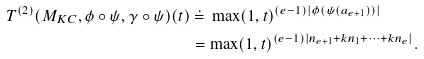Convert formula to latex. <formula><loc_0><loc_0><loc_500><loc_500>T ^ { ( 2 ) } ( M _ { K C } , \phi \circ \psi , \gamma \circ \psi ) ( t ) & \ \dot { = } \ \max ( 1 , t ) ^ { ( e - 1 ) | \phi ( \psi ( a _ { e + 1 } ) ) | } \\ & = \max ( 1 , t ) ^ { ( e - 1 ) | n _ { e + 1 } + k n _ { 1 } + \dots + k n _ { e } | } .</formula> 